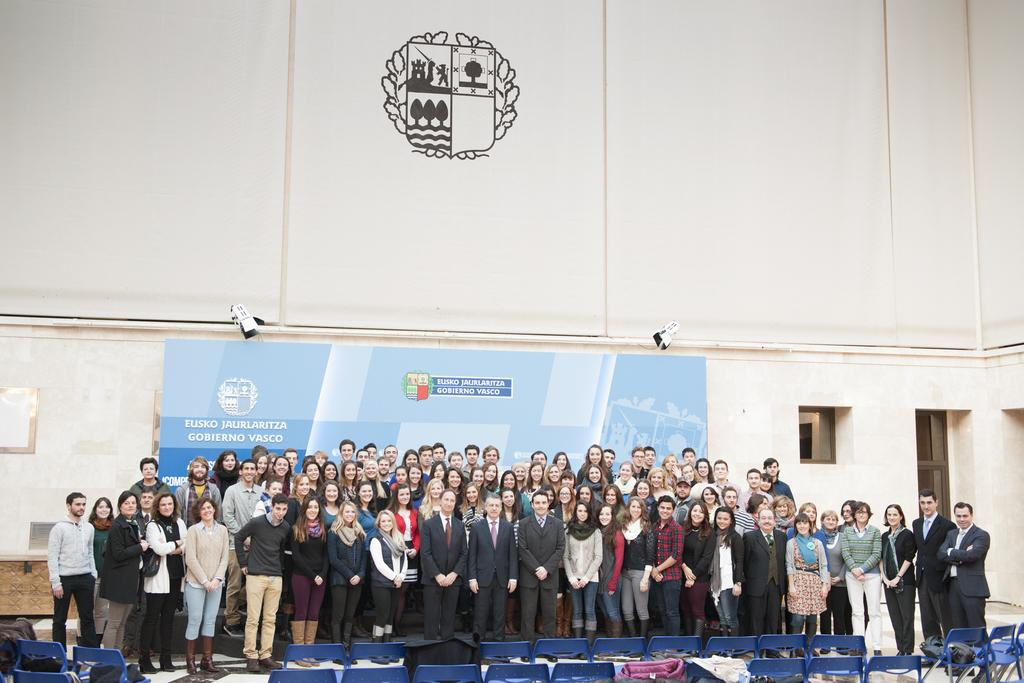How many persons are in the image? There are many persons standing in the center of the image. Where are the persons standing? The persons are standing on the floor. What objects are at the bottom of the image? There are chairs at the bottom of the image. What can be seen in the background of the image? There are lights, an advertisement, a window, a door, and a wall in the background of the image. What type of insurance policy is being advertised in the image? There is no insurance policy being advertised in the image; there is only an advertisement in the background. 